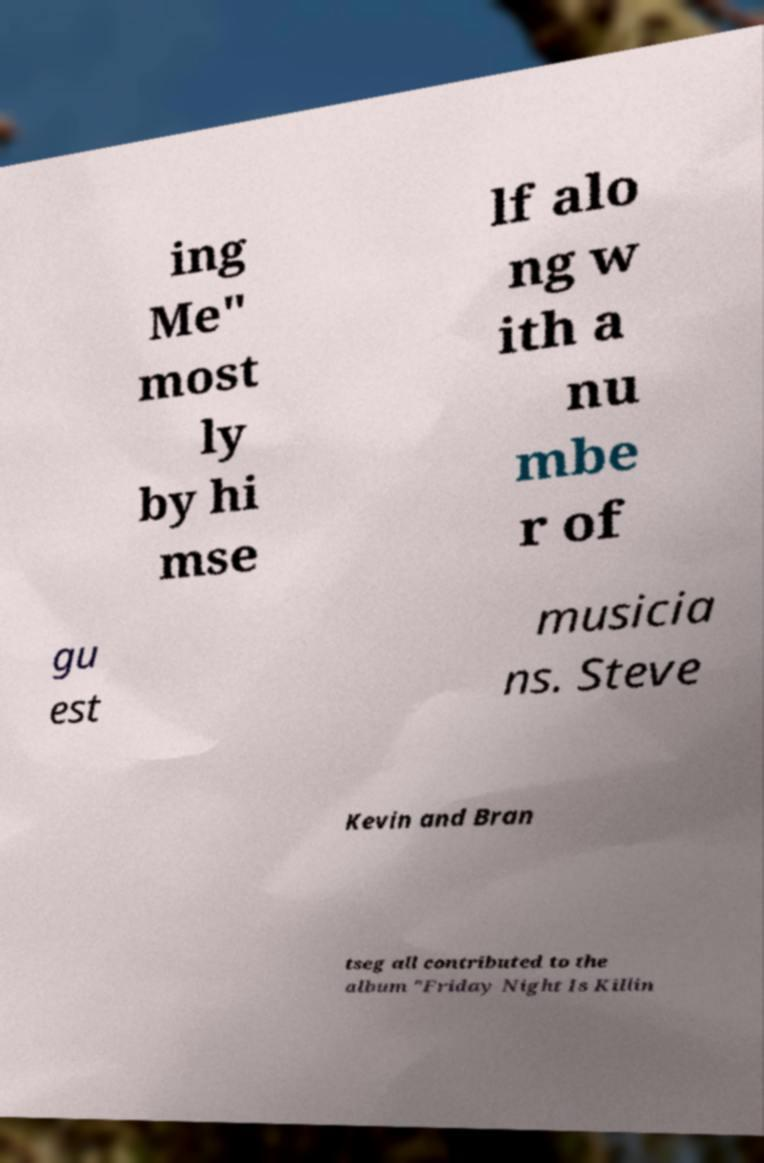For documentation purposes, I need the text within this image transcribed. Could you provide that? ing Me" most ly by hi mse lf alo ng w ith a nu mbe r of gu est musicia ns. Steve Kevin and Bran tseg all contributed to the album "Friday Night Is Killin 